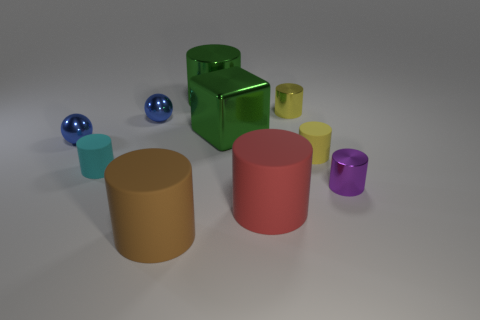How many balls are big brown matte things or green objects? In the image, there are no big brown matte balls; however, there are two big green objects, which include one large green cylinder and one shiny green cube. Therefore, the answer is two green objects fitting the description provided. 